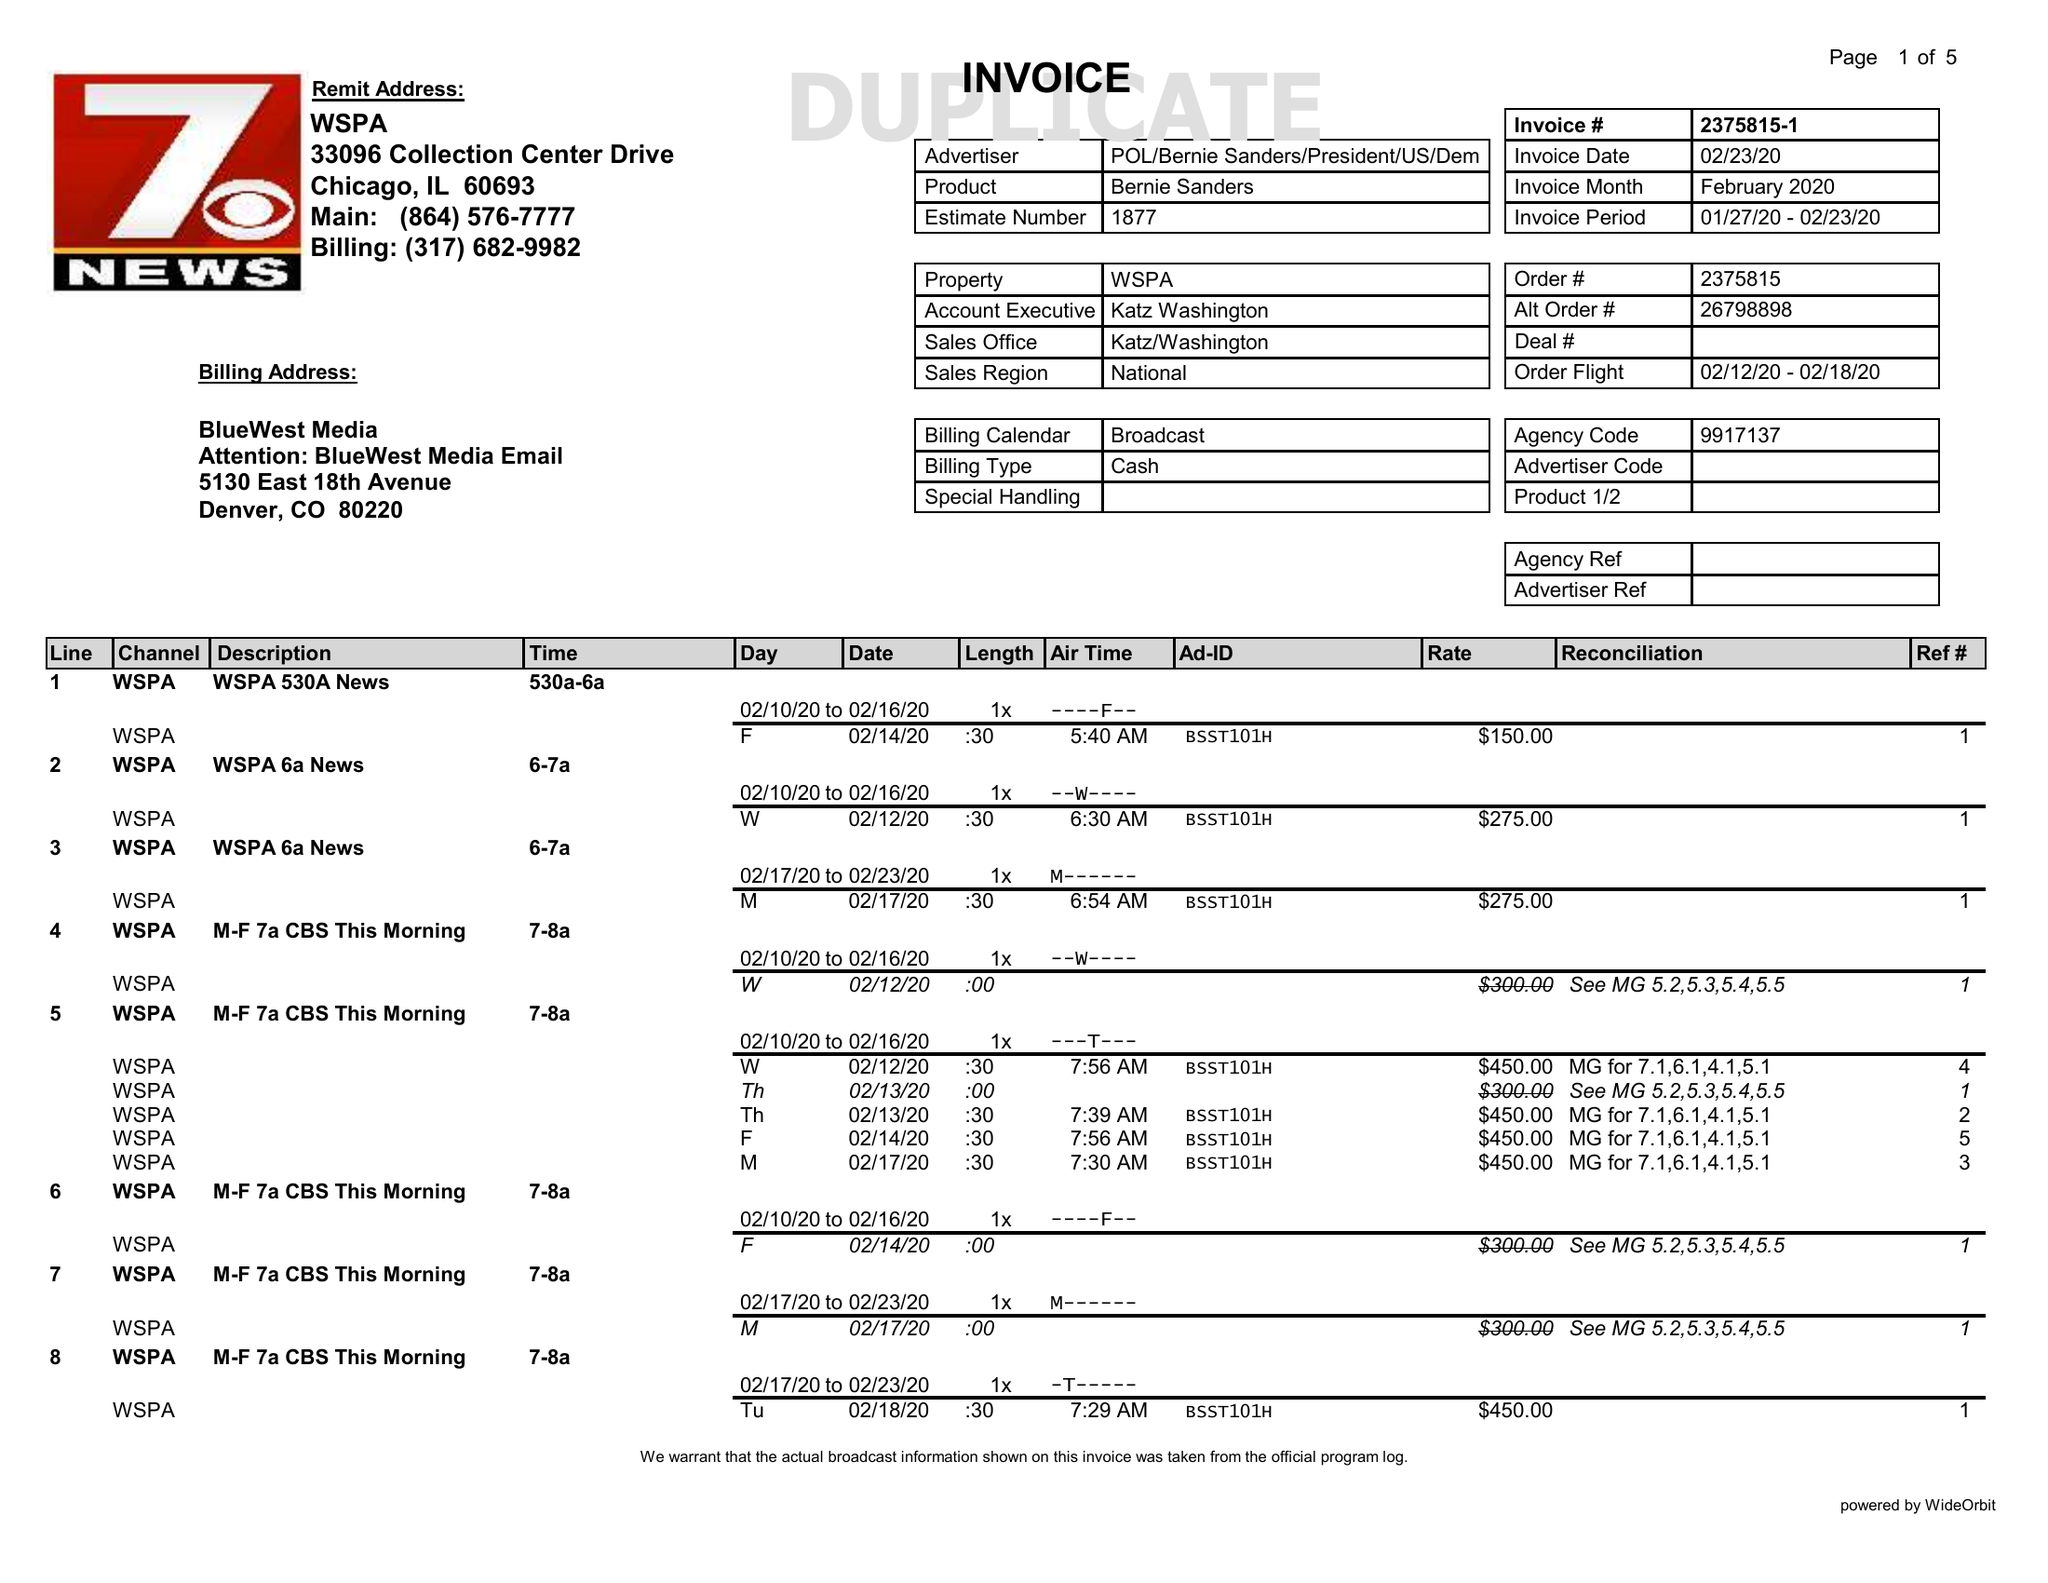What is the value for the contract_num?
Answer the question using a single word or phrase. 2375815 